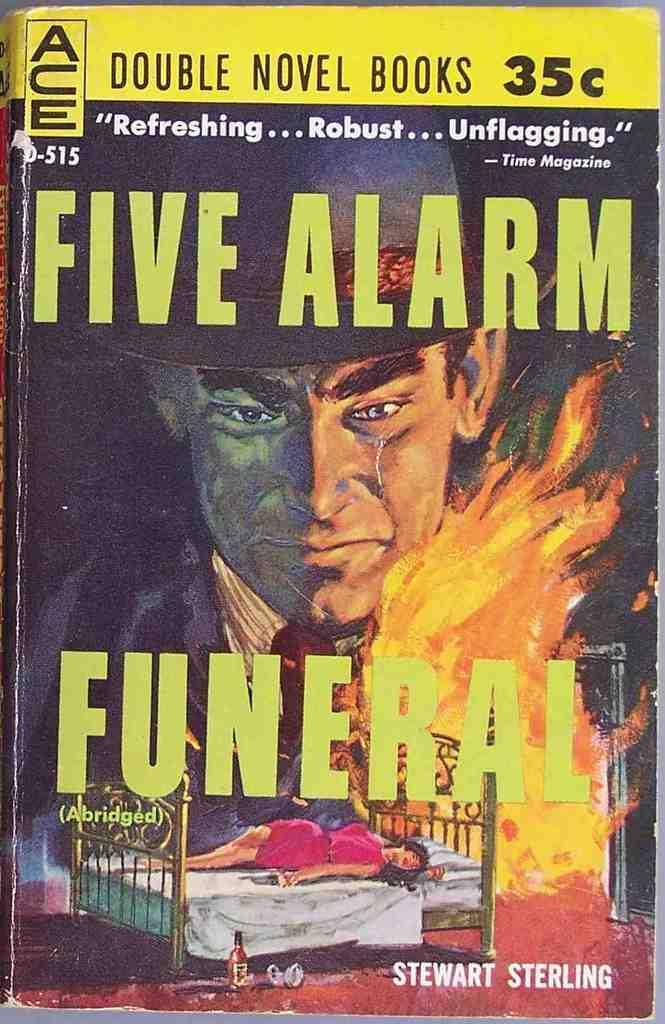<image>
Create a compact narrative representing the image presented. Cover for Five Alarm Funeral which costs 35 cents. 